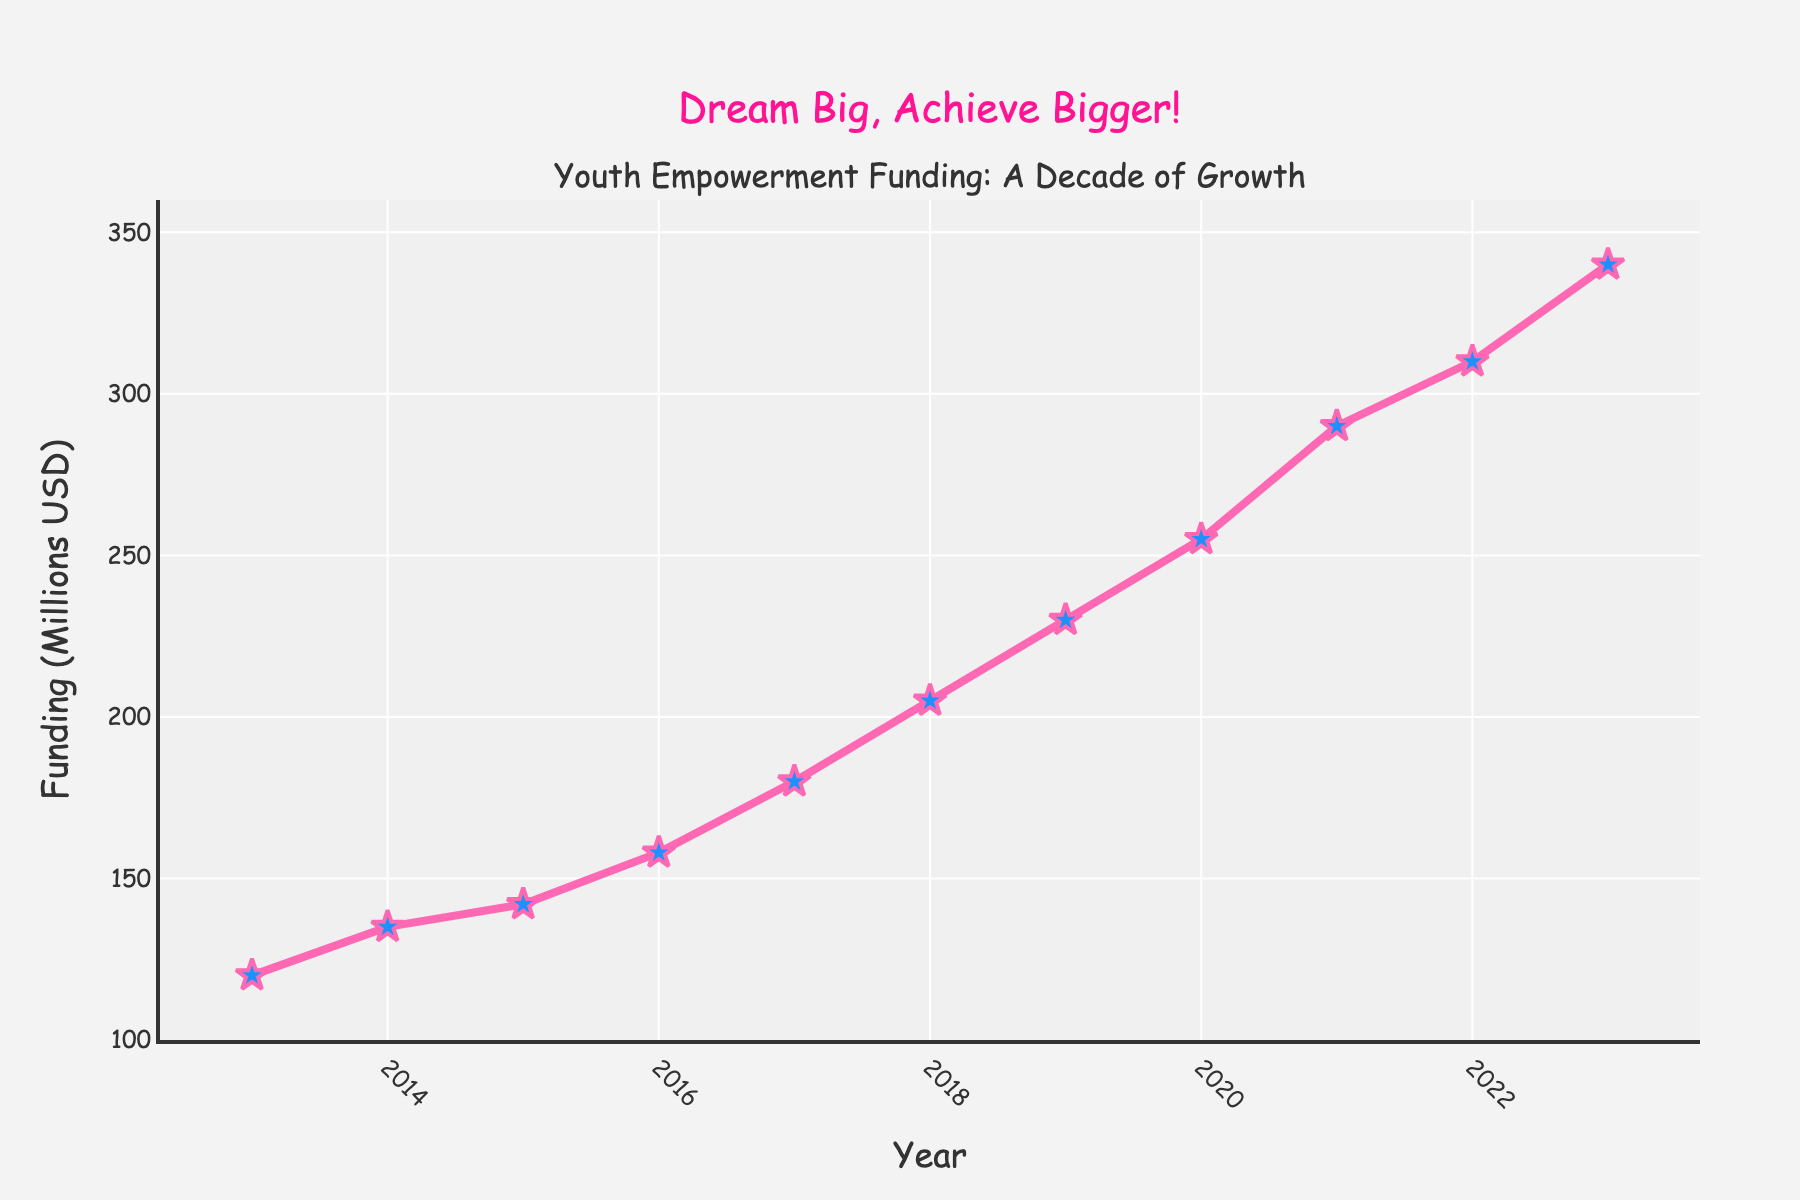What's the trend of funding for youth empowerment programs from 2013 to 2023? The line chart shows a general upward trend in funding for youth empowerment programs. Each year, the funding increases compared to the previous year. The trend indicates consistent growth over the last decade.
Answer: Upward By how much did the funding increase between 2016 and 2020? Funding in 2016 was 158, and in 2020 it was 255. Subtract the funding of 2016 from that of 2020 to find the increase: 255 - 158 = 97.
Answer: 97 million USD Which year saw the highest increase in funding compared to the previous year? Looking at the increments between consecutive years, the largest increase is between 2022 and 2023. Funding increased from 310 to 340, a difference of 30.
Answer: 2023 What's the average annual funding between 2018 and 2023? To find the average, sum the annual funding from 2018 to 2023: (205 + 230 + 255 + 290 + 310 + 340) = 1630, then divide by the number of years: 1630 / 6 = 271.67.
Answer: 271.67 million USD How does the funding in 2021 compare to that in 2017? The funding in 2021 was 290, and in 2017 it was 180. Subtracting the two gives the difference: 290 - 180 = 110. Thus, the funding in 2021 is significantly higher than in 2017 by 110 million USD.
Answer: 110 million USD higher What is the total funding from 2013 to 2018? Sum the funding from 2013 to 2018: 120 + 135 + 142 + 158 + 180 + 205 = 940.
Answer: 940 million USD Is the line representing the funding trend smooth or does it have noticeable variations? The line is relatively smooth with consistent yearly increases. No significant drops or spikes are seen.
Answer: Smooth During which interval was there the smallest increase in funding? Comparing increments between years, the smallest increase happens between 2014 (135) and 2015 (142), which is an increase of 7.
Answer: 2014-2015 What color represents the markers for the funding data points? The markers for the funding data points are described as blue stars with pink outlines.
Answer: Blue and pink What message is conveyed by the annotation on the figure, and where is it located? The annotation reads "Dream Big, Achieve Bigger!" and is located above the main plot area, roughly centered.
Answer: "Dream Big, Achieve Bigger!", centered above the plot 